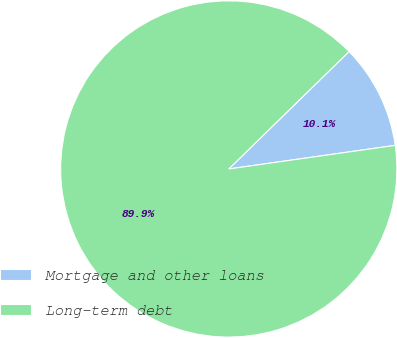<chart> <loc_0><loc_0><loc_500><loc_500><pie_chart><fcel>Mortgage and other loans<fcel>Long-term debt<nl><fcel>10.07%<fcel>89.93%<nl></chart> 